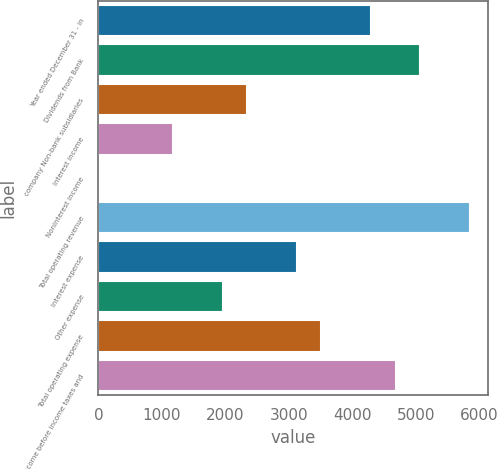Convert chart. <chart><loc_0><loc_0><loc_500><loc_500><bar_chart><fcel>Year ended December 31 - in<fcel>Dividends from Bank<fcel>company Non-bank subsidiaries<fcel>Interest income<fcel>Noninterest income<fcel>Total operating revenue<fcel>Interest expense<fcel>Other expense<fcel>Total operating expense<fcel>Income before income taxes and<nl><fcel>4292<fcel>5070<fcel>2347<fcel>1180<fcel>13<fcel>5848<fcel>3125<fcel>1958<fcel>3514<fcel>4681<nl></chart> 